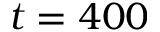<formula> <loc_0><loc_0><loc_500><loc_500>t = 4 0 0</formula> 